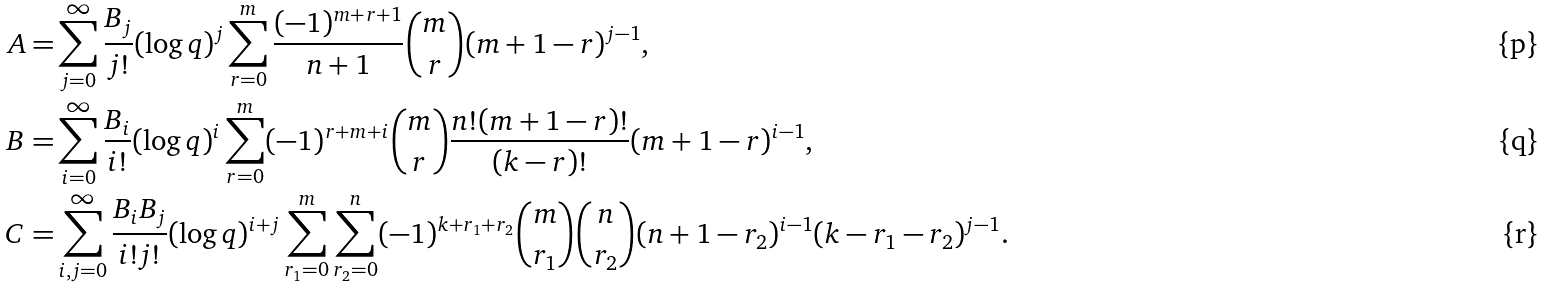Convert formula to latex. <formula><loc_0><loc_0><loc_500><loc_500>A = & \sum _ { j = 0 } ^ { \infty } \frac { B _ { j } } { j ! } ( \log q ) ^ { j } \sum _ { r = 0 } ^ { m } \frac { ( - 1 ) ^ { m + r + 1 } } { n + 1 } { m \choose r } ( m + 1 - r ) ^ { j - 1 } , \\ B = & \sum _ { i = 0 } ^ { \infty } \frac { B _ { i } } { i ! } ( \log q ) ^ { i } \sum _ { r = 0 } ^ { m } ( - 1 ) ^ { r + m + i } { m \choose r } \frac { n ! ( m + 1 - r ) ! } { ( k - r ) ! } ( m + 1 - r ) ^ { i - 1 } , \\ C = & \sum _ { i , j = 0 } ^ { \infty } \frac { B _ { i } B _ { j } } { i ! j ! } ( \log q ) ^ { i + j } \sum _ { r _ { 1 } = 0 } ^ { m } \sum _ { r _ { 2 } = 0 } ^ { n } ( - 1 ) ^ { k + r _ { 1 } + r _ { 2 } } { m \choose r _ { 1 } } { n \choose r _ { 2 } } ( n + 1 - r _ { 2 } ) ^ { i - 1 } ( k - r _ { 1 } - r _ { 2 } ) ^ { j - 1 } .</formula> 